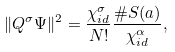Convert formula to latex. <formula><loc_0><loc_0><loc_500><loc_500>\| Q ^ { \sigma } \Psi \| ^ { 2 } = \frac { \chi _ { i d } ^ { \sigma } } { N ! } \frac { \# S ( a ) } { \chi _ { i d } ^ { \alpha } } ,</formula> 